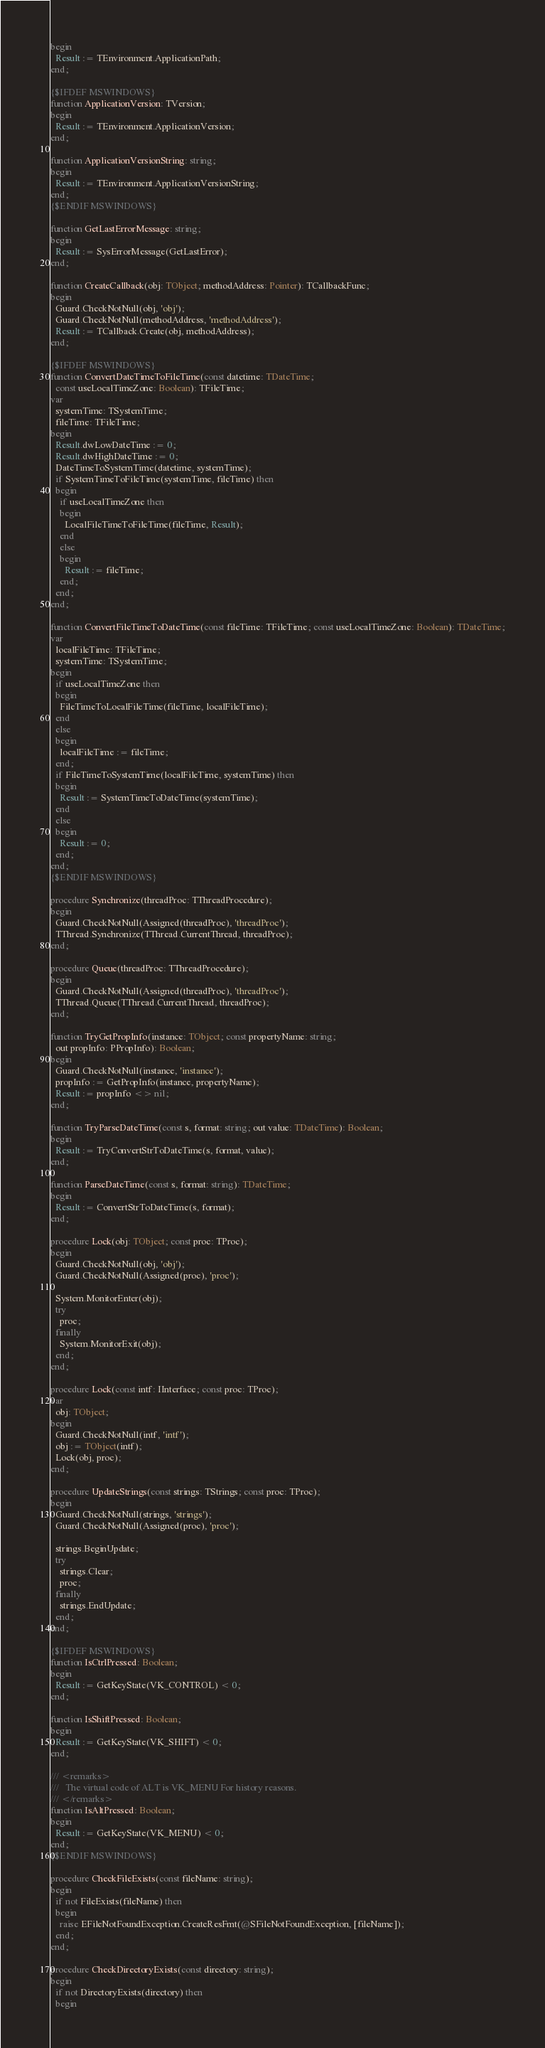Convert code to text. <code><loc_0><loc_0><loc_500><loc_500><_Pascal_>begin
  Result := TEnvironment.ApplicationPath;
end;

{$IFDEF MSWINDOWS}
function ApplicationVersion: TVersion;
begin
  Result := TEnvironment.ApplicationVersion;
end;

function ApplicationVersionString: string;
begin
  Result := TEnvironment.ApplicationVersionString;
end;
{$ENDIF MSWINDOWS}

function GetLastErrorMessage: string;
begin
  Result := SysErrorMessage(GetLastError);
end;

function CreateCallback(obj: TObject; methodAddress: Pointer): TCallbackFunc;
begin
  Guard.CheckNotNull(obj, 'obj');
  Guard.CheckNotNull(methodAddress, 'methodAddress');
  Result := TCallback.Create(obj, methodAddress);
end;

{$IFDEF MSWINDOWS}
function ConvertDateTimeToFileTime(const datetime: TDateTime;
  const useLocalTimeZone: Boolean): TFileTime;
var
  systemTime: TSystemTime;
  fileTime: TFileTime;
begin
  Result.dwLowDateTime := 0;
  Result.dwHighDateTime := 0;
  DateTimeToSystemTime(datetime, systemTime);
  if SystemTimeToFileTime(systemTime, fileTime) then
  begin
    if useLocalTimeZone then
    begin
      LocalFileTimeToFileTime(fileTime, Result);
    end
    else
    begin
      Result := fileTime;
    end;
  end;
end;

function ConvertFileTimeToDateTime(const fileTime: TFileTime; const useLocalTimeZone: Boolean): TDateTime;
var
  localFileTime: TFileTime;
  systemTime: TSystemTime;
begin
  if useLocalTimeZone then
  begin
    FileTimeToLocalFileTime(fileTime, localFileTime);
  end
  else
  begin
    localFileTime := fileTime;
  end;
  if FileTimeToSystemTime(localFileTime, systemTime) then
  begin
    Result := SystemTimeToDateTime(systemTime);
  end
  else
  begin
    Result := 0;
  end;
end;
{$ENDIF MSWINDOWS}

procedure Synchronize(threadProc: TThreadProcedure);
begin
  Guard.CheckNotNull(Assigned(threadProc), 'threadProc');
  TThread.Synchronize(TThread.CurrentThread, threadProc);
end;

procedure Queue(threadProc: TThreadProcedure);
begin
  Guard.CheckNotNull(Assigned(threadProc), 'threadProc');
  TThread.Queue(TThread.CurrentThread, threadProc);
end;

function TryGetPropInfo(instance: TObject; const propertyName: string;
  out propInfo: PPropInfo): Boolean;
begin
  Guard.CheckNotNull(instance, 'instance');
  propInfo := GetPropInfo(instance, propertyName);
  Result := propInfo <> nil;
end;

function TryParseDateTime(const s, format: string; out value: TDateTime): Boolean;
begin
  Result := TryConvertStrToDateTime(s, format, value);
end;

function ParseDateTime(const s, format: string): TDateTime;
begin
  Result := ConvertStrToDateTime(s, format);
end;

procedure Lock(obj: TObject; const proc: TProc);
begin
  Guard.CheckNotNull(obj, 'obj');
  Guard.CheckNotNull(Assigned(proc), 'proc');

  System.MonitorEnter(obj);
  try
    proc;
  finally
    System.MonitorExit(obj);
  end;
end;

procedure Lock(const intf: IInterface; const proc: TProc);
var
  obj: TObject;
begin
  Guard.CheckNotNull(intf, 'intf');
  obj := TObject(intf);
  Lock(obj, proc);
end;

procedure UpdateStrings(const strings: TStrings; const proc: TProc);
begin
  Guard.CheckNotNull(strings, 'strings');
  Guard.CheckNotNull(Assigned(proc), 'proc');

  strings.BeginUpdate;
  try
    strings.Clear;
    proc;
  finally
    strings.EndUpdate;
  end;
end;

{$IFDEF MSWINDOWS}
function IsCtrlPressed: Boolean;
begin
  Result := GetKeyState(VK_CONTROL) < 0;
end;

function IsShiftPressed: Boolean;
begin
  Result := GetKeyState(VK_SHIFT) < 0;
end;

/// <remarks>
///   The virtual code of ALT is VK_MENU For history reasons.
/// </remarks>
function IsAltPressed: Boolean;
begin
  Result := GetKeyState(VK_MENU) < 0;
end;
{$ENDIF MSWINDOWS}

procedure CheckFileExists(const fileName: string);
begin
  if not FileExists(fileName) then
  begin
    raise EFileNotFoundException.CreateResFmt(@SFileNotFoundException, [fileName]);
  end;
end;

procedure CheckDirectoryExists(const directory: string);
begin
  if not DirectoryExists(directory) then
  begin</code> 